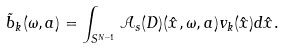<formula> <loc_0><loc_0><loc_500><loc_500>\tilde { b } _ { k } ( \omega , a ) = \int _ { S ^ { N - 1 } } \mathcal { A } _ { s } ( D ) ( \hat { x } , \omega , a ) v _ { k } ( \hat { x } ) d \hat { x } .</formula> 